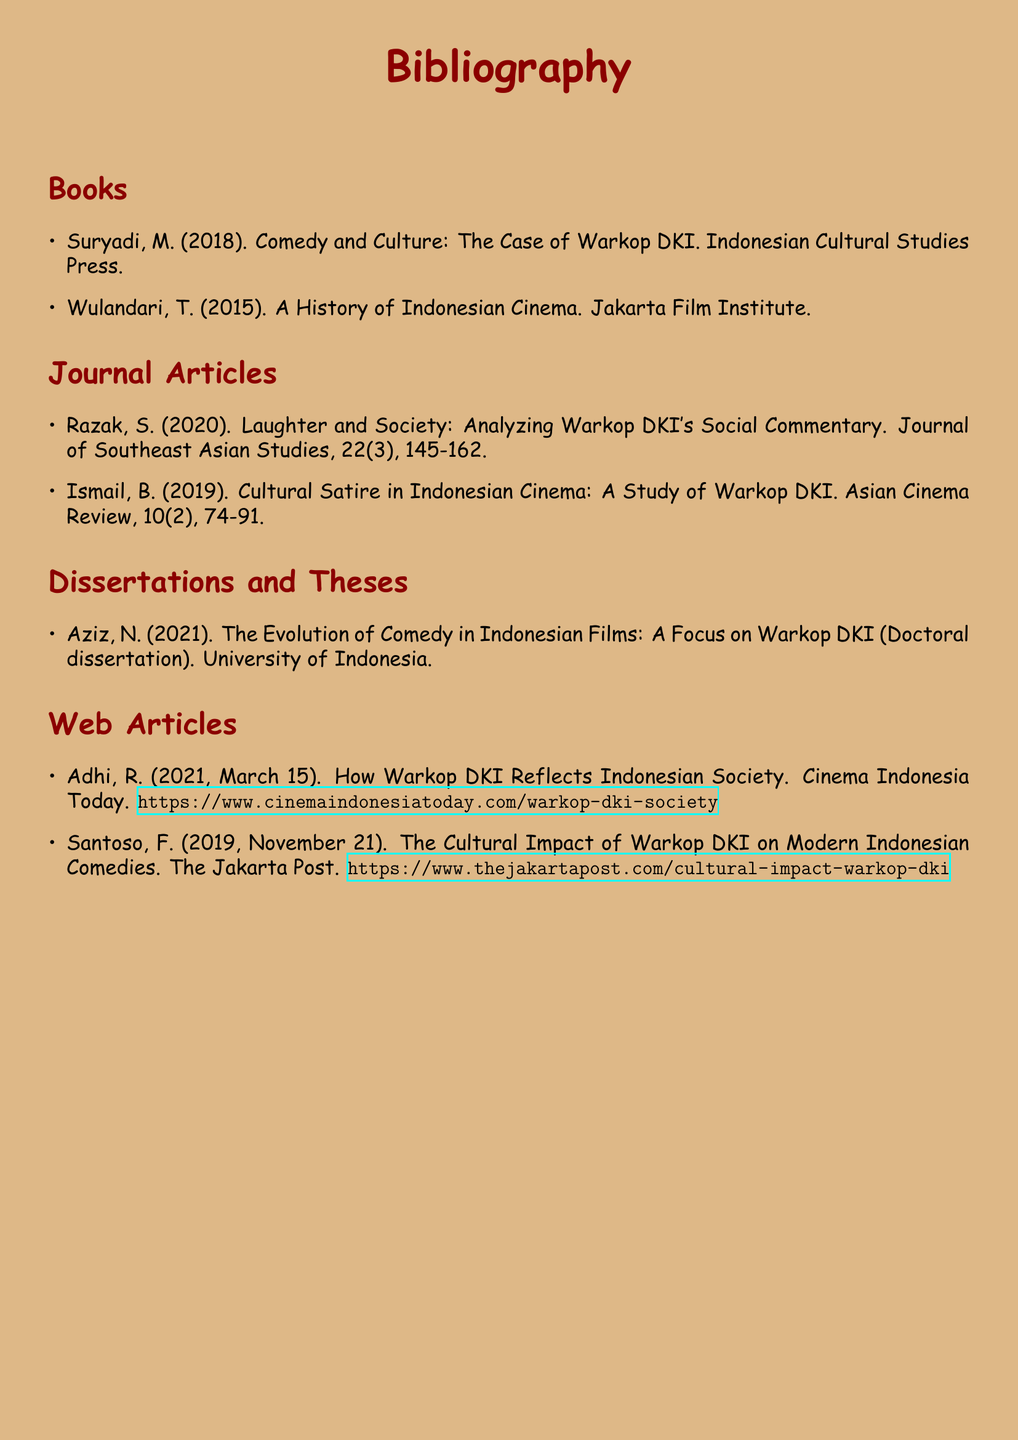What is the title of the book by Suryadi? The title given in the bibliography is critical for attribution and further reading.
Answer: Comedy and Culture: The Case of Warkop DKI How many journal articles are listed? The total number of journal articles provides insight into the depth of research covered.
Answer: 2 Who is the author of the dissertation on the evolution of comedy in Indonesian films? Knowing the author helps identify key contributors in the field of study.
Answer: Aziz, N What year was the article by Ismail published? The publication year of academic articles is essential for understanding contemporary relevance.
Answer: 2019 What is the URL for the article by Santoso? URLs are important for accessing the source material online for further exploration.
Answer: https://www.thejakartapost.com/cultural-impact-warkop-dki Which publication discusses Warkop DKI's social commentary? Identifying sources that analyze specific aspects of Warkop DKI is useful for focused research.
Answer: Journal of Southeast Asian Studies In what year did Wulandari publish her book? The publication year of books gives context to their relevance and timing in the literature.
Answer: 2015 What type of document is "The Evolution of Comedy in Indonesian Films"? Classifying the type of work helps in understanding the research approach used by the author.
Answer: Doctoral dissertation 